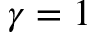<formula> <loc_0><loc_0><loc_500><loc_500>\gamma = 1</formula> 